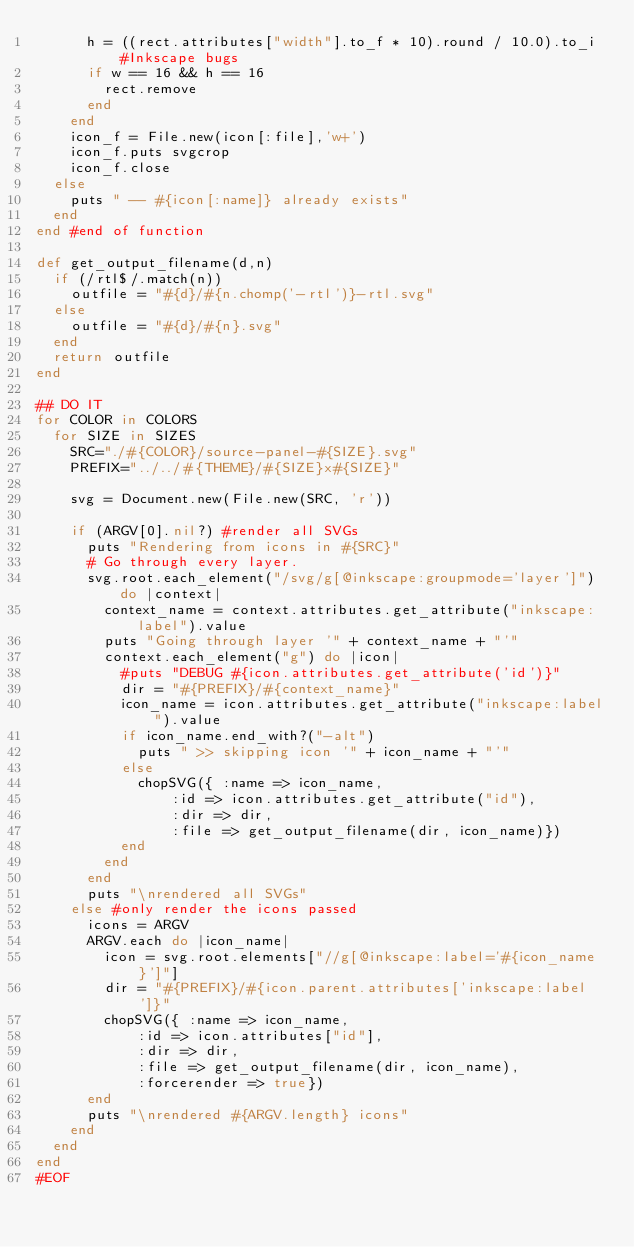<code> <loc_0><loc_0><loc_500><loc_500><_Ruby_>			h = ((rect.attributes["width"].to_f * 10).round / 10.0).to_i #Inkscape bugs
			if w == 16 && h == 16
				rect.remove
			end
		end
		icon_f = File.new(icon[:file],'w+')
		icon_f.puts svgcrop
		icon_f.close
	else
		puts " -- #{icon[:name]} already exists"
	end
end #end of function

def get_output_filename(d,n)
	if (/rtl$/.match(n))
		outfile = "#{d}/#{n.chomp('-rtl')}-rtl.svg"
	else
		outfile = "#{d}/#{n}.svg"
	end
	return outfile
end

## DO IT
for COLOR in COLORS
	for SIZE in SIZES
		SRC="./#{COLOR}/source-panel-#{SIZE}.svg"
		PREFIX="../../#{THEME}/#{SIZE}x#{SIZE}"

		svg = Document.new(File.new(SRC, 'r'))

		if (ARGV[0].nil?) #render all SVGs
			puts "Rendering from icons in #{SRC}"
			# Go through every layer.
			svg.root.each_element("/svg/g[@inkscape:groupmode='layer']") do |context| 
				context_name = context.attributes.get_attribute("inkscape:label").value  
				puts "Going through layer '" + context_name + "'"
				context.each_element("g") do |icon|
					#puts "DEBUG #{icon.attributes.get_attribute('id')}"
					dir = "#{PREFIX}/#{context_name}"
					icon_name = icon.attributes.get_attribute("inkscape:label").value
					if icon_name.end_with?("-alt")
						puts " >> skipping icon '" + icon_name + "'"
					else
						chopSVG({ :name => icon_name,
								:id => icon.attributes.get_attribute("id"),
								:dir => dir,
								:file => get_output_filename(dir, icon_name)})
					end
				end
			end
			puts "\nrendered all SVGs"
		else #only render the icons passed
			icons = ARGV
			ARGV.each do |icon_name|
				icon = svg.root.elements["//g[@inkscape:label='#{icon_name}']"]
				dir = "#{PREFIX}/#{icon.parent.attributes['inkscape:label']}"
				chopSVG({ :name => icon_name,
						:id => icon.attributes["id"],
						:dir => dir,
						:file => get_output_filename(dir, icon_name),
						:forcerender => true})
			end
			puts "\nrendered #{ARGV.length} icons"
		end
	end
end
#EOF</code> 